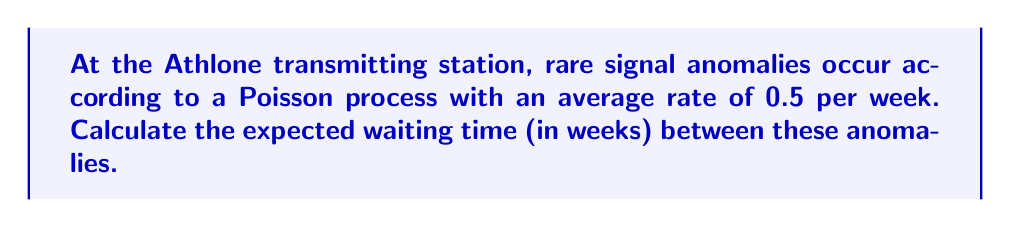Can you answer this question? Let's approach this step-by-step:

1) In a Poisson process, the waiting time between events follows an exponential distribution.

2) The parameter λ of the exponential distribution is the same as the rate of the Poisson process.

3) Given:
   λ = 0.5 anomalies per week

4) For an exponential distribution, the expected value (mean) is given by:

   $$E[X] = \frac{1}{\lambda}$$

5) Substituting our λ value:

   $$E[X] = \frac{1}{0.5} = 2$$

6) Therefore, the expected waiting time between anomalies is 2 weeks.

This means that, on average, you would expect to wait 2 weeks between rare signal anomalies at the Athlone transmitting station.
Answer: 2 weeks 